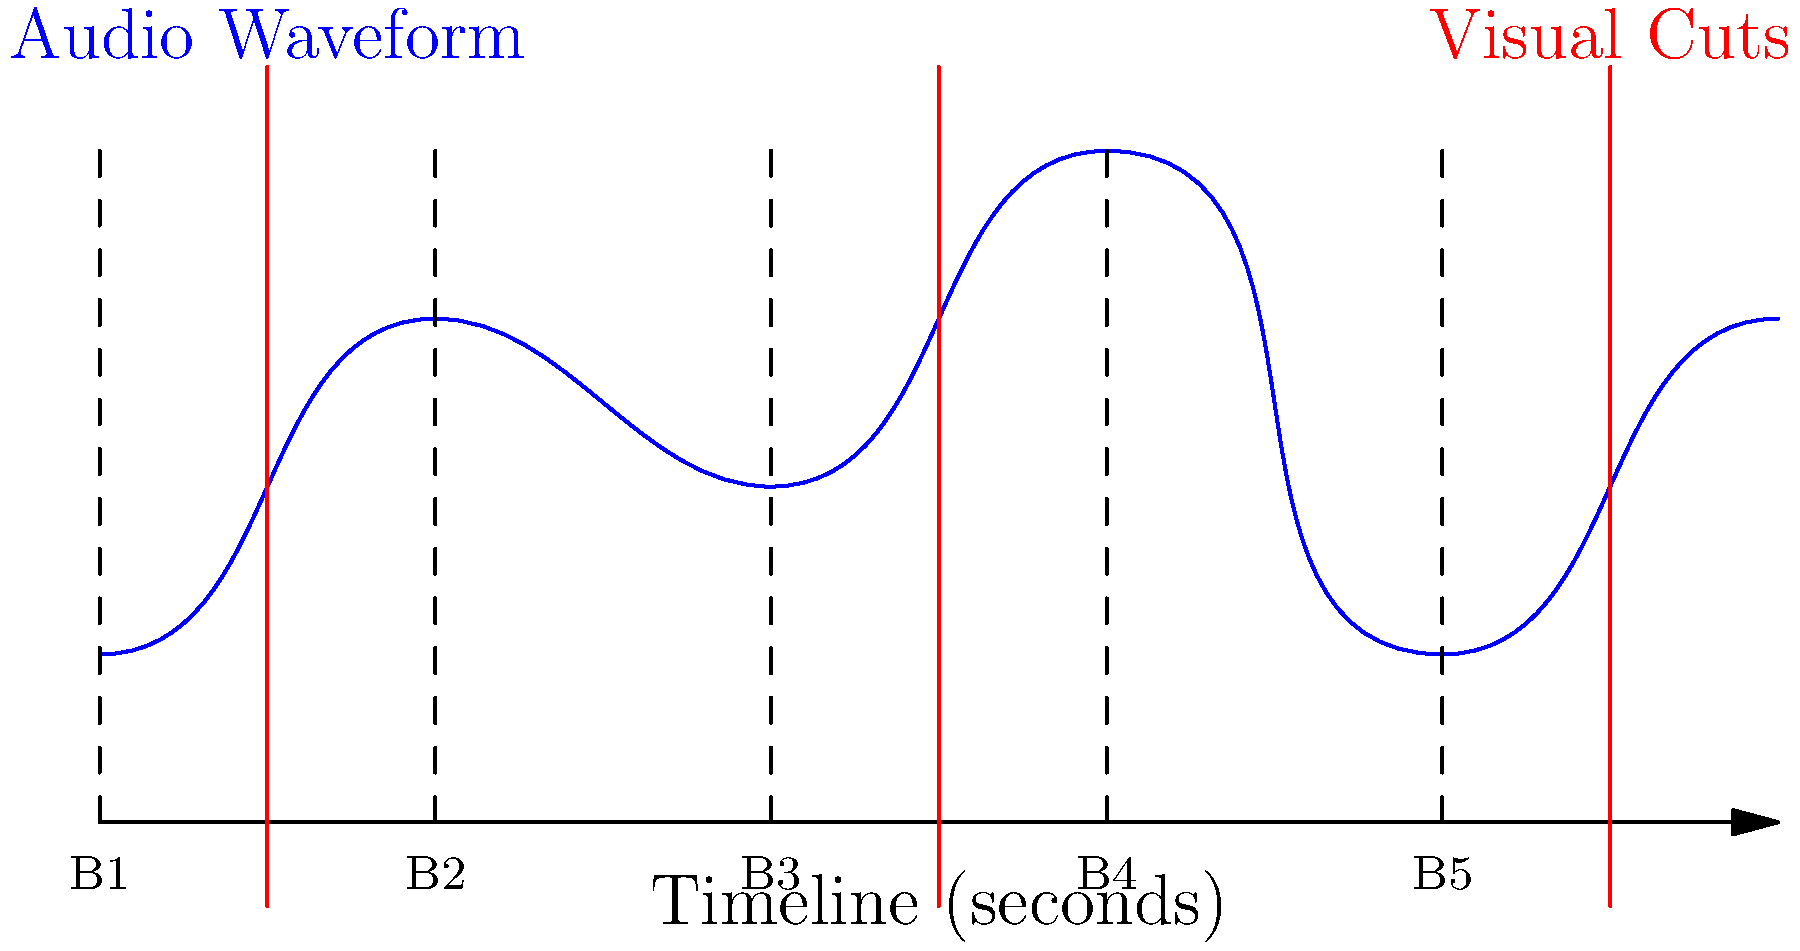In the timeline above, which beat marker aligns most closely with the second visual cut, and what editing technique does this represent in anime music video creation? To answer this question, let's analyze the timeline step-by-step:

1. The timeline shows 10 seconds of video, with beat markers (B1 to B5) every 2 seconds.
2. There are three visual cuts represented by red vertical lines at approximately 1, 5, and 9 seconds.
3. The second visual cut is at the 5-second mark.
4. Looking at the beat markers, we can see that B3 is precisely at the 4-second mark.
5. The second visual cut (at 5 seconds) is closest to B3 (at 4 seconds).
6. This alignment represents a common editing technique in anime music videos called "cutting on the beat" or "beat matching."
7. In this technique, visual transitions are timed to occur slightly after a musical beat, creating a sense of rhythm and synchronization between the visuals and the audio.
8. The slight delay (in this case, about 1 second) between the beat and the cut is often used to maintain a natural flow and prevent the editing from feeling too mechanical or predictable.

This technique enhances the overall impact of the anime music video by creating a harmonious relationship between the music and the visuals, making the viewing experience more engaging and dynamic.
Answer: B3; beat matching 